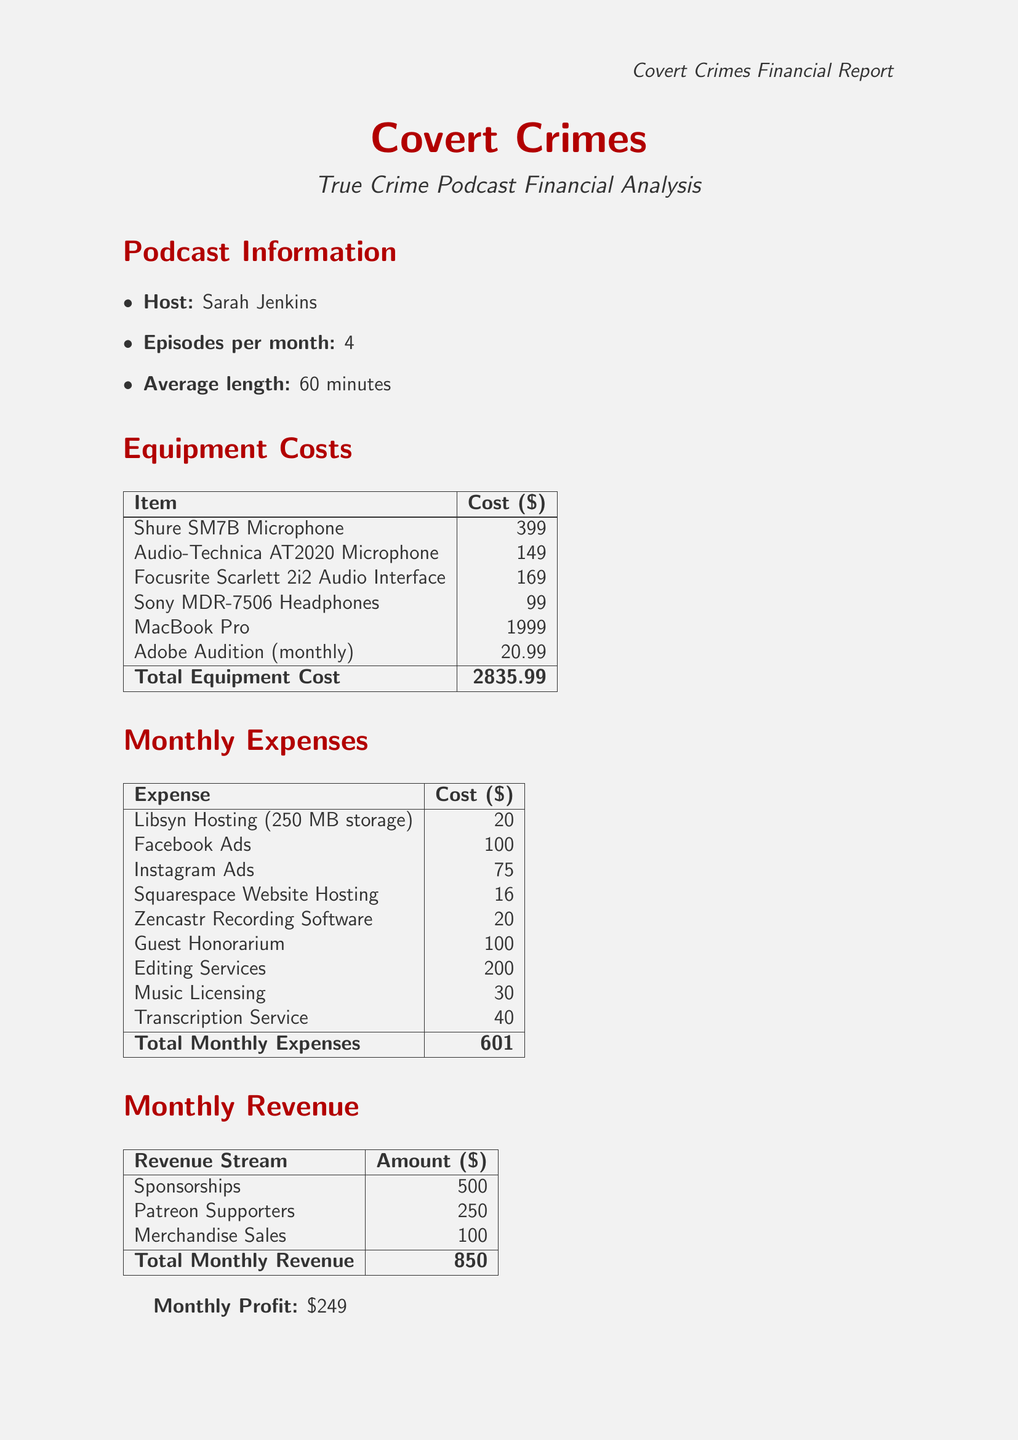What is the name of the podcast? The name of the podcast is specified in the document under podcast information.
Answer: Covert Crimes Who is the host of the podcast? The document provides the name of the host in the podcast information section.
Answer: Sarah Jenkins What is the total equipment cost? The total equipment cost is calculated as the sum of individual equipment costs listed in the document.
Answer: 2835.99 What is the monthly fee for hosting? The document states the monthly fee for hosting services under hosting expenses.
Answer: 20 How much are Instagram ads? The document lists the cost of Instagram ads in the marketing costs section.
Answer: 75 What is the total monthly revenue? The total monthly revenue is derived from adding all revenue sources shown in the document.
Answer: 850 What are guest honorarium expenses? The document specifies the cost associated with guest honorarium as part of guest-related expenses.
Answer: 100 What is the monthly profit? The monthly profit is determined by subtracting the total monthly expenses from the total monthly revenue in the document.
Answer: 249 How much is the Zencastr recording software? The cost for Zencastr recording software is provided in the guest-related expenses section.
Answer: 20 